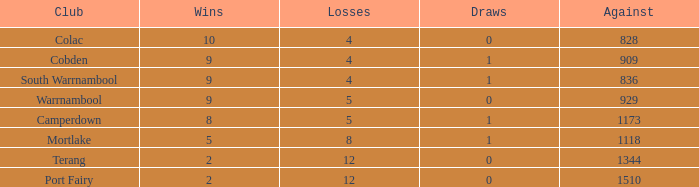What is the average number of draws for losses over 8 and Against values under 1344? None. 